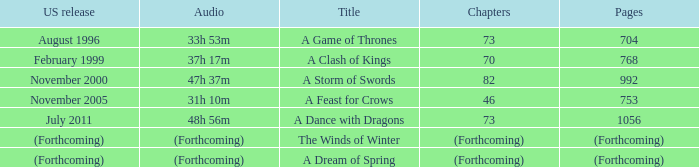Which audio has a Title of a storm of swords? 47h 37m. 